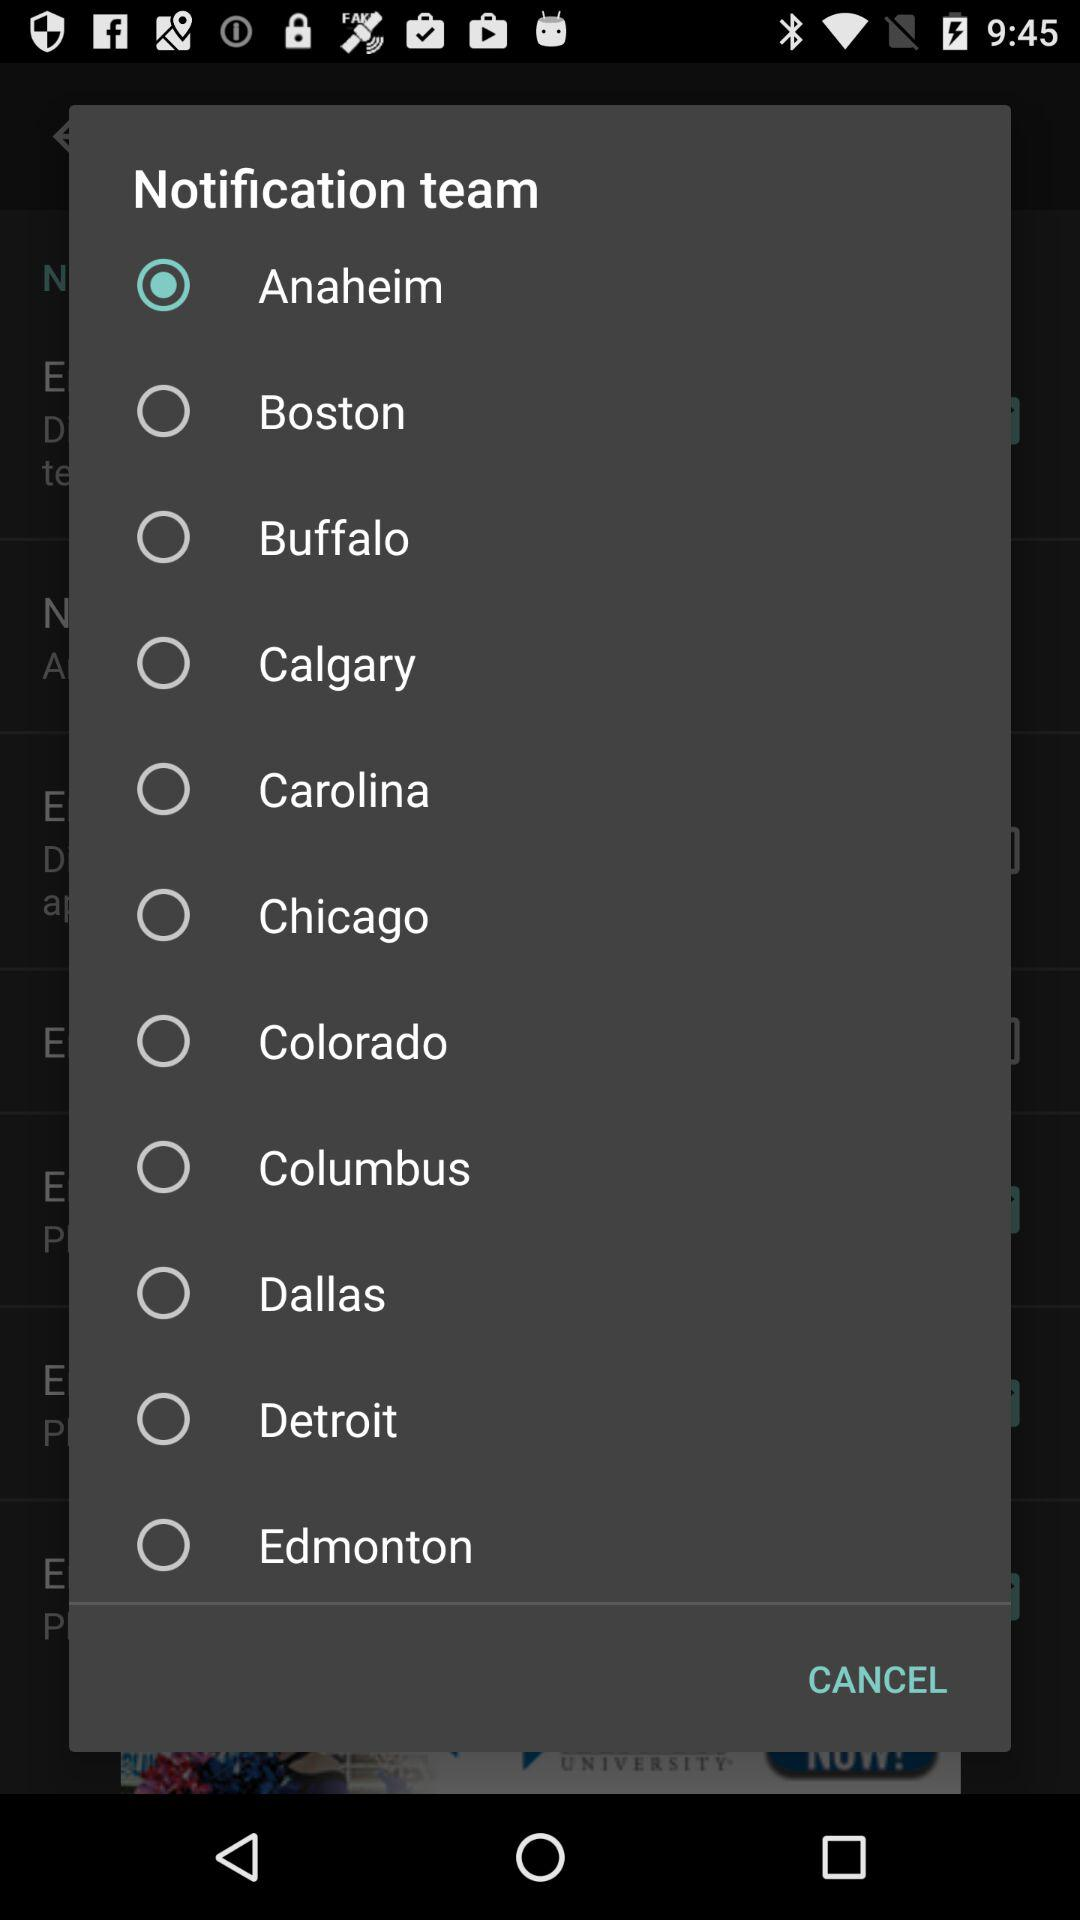Which city is selected? The selected city is "Anaheim". 